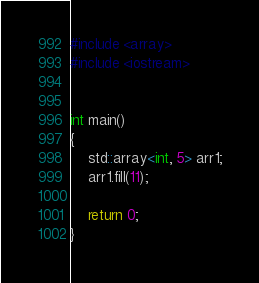Convert code to text. <code><loc_0><loc_0><loc_500><loc_500><_C++_>
#include <array>
#include <iostream>


int main()
{
	std::array<int, 5> arr1;
	arr1.fill(11);
		
	return 0;
}</code> 